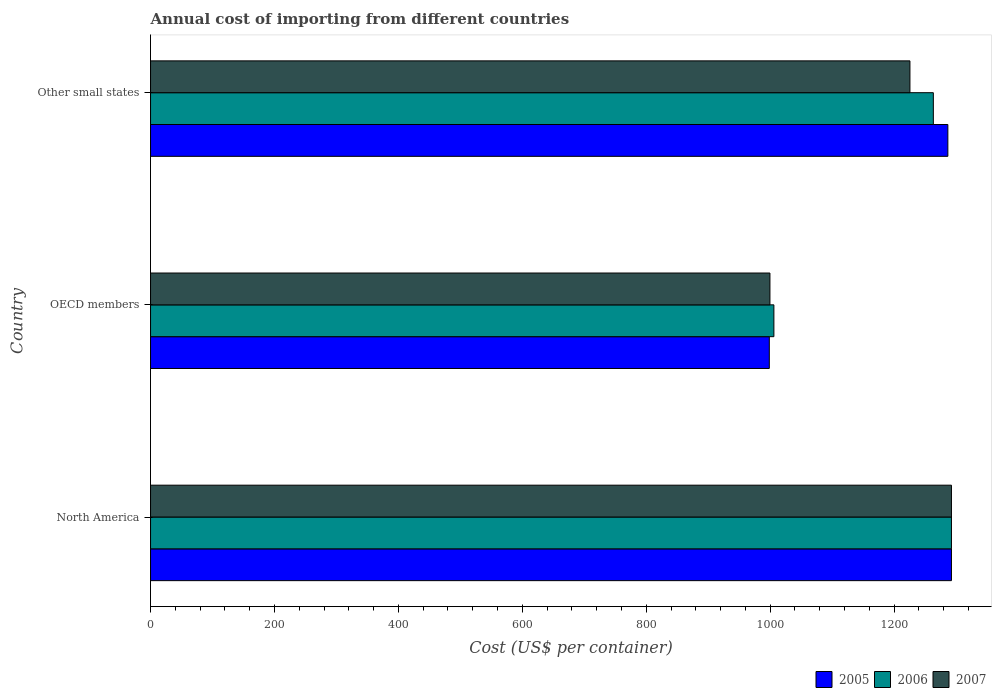How many different coloured bars are there?
Ensure brevity in your answer.  3. How many groups of bars are there?
Your answer should be compact. 3. Are the number of bars per tick equal to the number of legend labels?
Your response must be concise. Yes. Are the number of bars on each tick of the Y-axis equal?
Provide a short and direct response. Yes. How many bars are there on the 1st tick from the bottom?
Give a very brief answer. 3. What is the total annual cost of importing in 2005 in North America?
Your answer should be compact. 1292.5. Across all countries, what is the maximum total annual cost of importing in 2007?
Give a very brief answer. 1292.5. Across all countries, what is the minimum total annual cost of importing in 2007?
Provide a short and direct response. 999.59. In which country was the total annual cost of importing in 2006 maximum?
Offer a terse response. North America. In which country was the total annual cost of importing in 2005 minimum?
Give a very brief answer. OECD members. What is the total total annual cost of importing in 2006 in the graph?
Ensure brevity in your answer.  3561.75. What is the difference between the total annual cost of importing in 2006 in OECD members and that in Other small states?
Provide a succinct answer. -257.31. What is the difference between the total annual cost of importing in 2005 in North America and the total annual cost of importing in 2007 in OECD members?
Ensure brevity in your answer.  292.91. What is the average total annual cost of importing in 2007 per country?
Give a very brief answer. 1172.53. What is the difference between the total annual cost of importing in 2006 and total annual cost of importing in 2005 in OECD members?
Your answer should be compact. 7.39. What is the ratio of the total annual cost of importing in 2007 in North America to that in Other small states?
Provide a short and direct response. 1.05. What is the difference between the highest and the second highest total annual cost of importing in 2006?
Your answer should be compact. 29.22. What is the difference between the highest and the lowest total annual cost of importing in 2005?
Provide a succinct answer. 293.92. Is the sum of the total annual cost of importing in 2006 in OECD members and Other small states greater than the maximum total annual cost of importing in 2007 across all countries?
Keep it short and to the point. Yes. How many bars are there?
Your response must be concise. 9. How many countries are there in the graph?
Give a very brief answer. 3. What is the difference between two consecutive major ticks on the X-axis?
Offer a terse response. 200. Does the graph contain any zero values?
Ensure brevity in your answer.  No. How are the legend labels stacked?
Offer a very short reply. Horizontal. What is the title of the graph?
Provide a succinct answer. Annual cost of importing from different countries. Does "2012" appear as one of the legend labels in the graph?
Ensure brevity in your answer.  No. What is the label or title of the X-axis?
Offer a terse response. Cost (US$ per container). What is the label or title of the Y-axis?
Provide a short and direct response. Country. What is the Cost (US$ per container) of 2005 in North America?
Ensure brevity in your answer.  1292.5. What is the Cost (US$ per container) in 2006 in North America?
Provide a succinct answer. 1292.5. What is the Cost (US$ per container) of 2007 in North America?
Offer a terse response. 1292.5. What is the Cost (US$ per container) of 2005 in OECD members?
Keep it short and to the point. 998.58. What is the Cost (US$ per container) in 2006 in OECD members?
Offer a very short reply. 1005.97. What is the Cost (US$ per container) in 2007 in OECD members?
Offer a very short reply. 999.59. What is the Cost (US$ per container) in 2005 in Other small states?
Make the answer very short. 1286.71. What is the Cost (US$ per container) of 2006 in Other small states?
Your response must be concise. 1263.28. What is the Cost (US$ per container) of 2007 in Other small states?
Offer a terse response. 1225.5. Across all countries, what is the maximum Cost (US$ per container) of 2005?
Provide a short and direct response. 1292.5. Across all countries, what is the maximum Cost (US$ per container) in 2006?
Give a very brief answer. 1292.5. Across all countries, what is the maximum Cost (US$ per container) of 2007?
Your answer should be very brief. 1292.5. Across all countries, what is the minimum Cost (US$ per container) of 2005?
Ensure brevity in your answer.  998.58. Across all countries, what is the minimum Cost (US$ per container) of 2006?
Ensure brevity in your answer.  1005.97. Across all countries, what is the minimum Cost (US$ per container) in 2007?
Give a very brief answer. 999.59. What is the total Cost (US$ per container) of 2005 in the graph?
Offer a terse response. 3577.78. What is the total Cost (US$ per container) in 2006 in the graph?
Offer a terse response. 3561.75. What is the total Cost (US$ per container) of 2007 in the graph?
Your response must be concise. 3517.59. What is the difference between the Cost (US$ per container) in 2005 in North America and that in OECD members?
Keep it short and to the point. 293.92. What is the difference between the Cost (US$ per container) of 2006 in North America and that in OECD members?
Offer a very short reply. 286.53. What is the difference between the Cost (US$ per container) in 2007 in North America and that in OECD members?
Keep it short and to the point. 292.91. What is the difference between the Cost (US$ per container) of 2005 in North America and that in Other small states?
Provide a succinct answer. 5.79. What is the difference between the Cost (US$ per container) in 2006 in North America and that in Other small states?
Provide a succinct answer. 29.22. What is the difference between the Cost (US$ per container) of 2005 in OECD members and that in Other small states?
Your answer should be very brief. -288.13. What is the difference between the Cost (US$ per container) in 2006 in OECD members and that in Other small states?
Give a very brief answer. -257.31. What is the difference between the Cost (US$ per container) of 2007 in OECD members and that in Other small states?
Your response must be concise. -225.91. What is the difference between the Cost (US$ per container) of 2005 in North America and the Cost (US$ per container) of 2006 in OECD members?
Keep it short and to the point. 286.53. What is the difference between the Cost (US$ per container) in 2005 in North America and the Cost (US$ per container) in 2007 in OECD members?
Your answer should be very brief. 292.91. What is the difference between the Cost (US$ per container) in 2006 in North America and the Cost (US$ per container) in 2007 in OECD members?
Your answer should be compact. 292.91. What is the difference between the Cost (US$ per container) of 2005 in North America and the Cost (US$ per container) of 2006 in Other small states?
Your answer should be compact. 29.22. What is the difference between the Cost (US$ per container) in 2005 in OECD members and the Cost (US$ per container) in 2006 in Other small states?
Your answer should be compact. -264.7. What is the difference between the Cost (US$ per container) of 2005 in OECD members and the Cost (US$ per container) of 2007 in Other small states?
Your answer should be compact. -226.92. What is the difference between the Cost (US$ per container) of 2006 in OECD members and the Cost (US$ per container) of 2007 in Other small states?
Offer a very short reply. -219.53. What is the average Cost (US$ per container) of 2005 per country?
Keep it short and to the point. 1192.59. What is the average Cost (US$ per container) of 2006 per country?
Offer a very short reply. 1187.25. What is the average Cost (US$ per container) in 2007 per country?
Offer a terse response. 1172.53. What is the difference between the Cost (US$ per container) in 2005 and Cost (US$ per container) in 2007 in North America?
Offer a terse response. 0. What is the difference between the Cost (US$ per container) of 2006 and Cost (US$ per container) of 2007 in North America?
Provide a short and direct response. 0. What is the difference between the Cost (US$ per container) in 2005 and Cost (US$ per container) in 2006 in OECD members?
Your answer should be very brief. -7.39. What is the difference between the Cost (US$ per container) of 2005 and Cost (US$ per container) of 2007 in OECD members?
Give a very brief answer. -1.01. What is the difference between the Cost (US$ per container) of 2006 and Cost (US$ per container) of 2007 in OECD members?
Provide a succinct answer. 6.38. What is the difference between the Cost (US$ per container) in 2005 and Cost (US$ per container) in 2006 in Other small states?
Your answer should be compact. 23.43. What is the difference between the Cost (US$ per container) of 2005 and Cost (US$ per container) of 2007 in Other small states?
Provide a short and direct response. 61.21. What is the difference between the Cost (US$ per container) in 2006 and Cost (US$ per container) in 2007 in Other small states?
Offer a terse response. 37.78. What is the ratio of the Cost (US$ per container) of 2005 in North America to that in OECD members?
Ensure brevity in your answer.  1.29. What is the ratio of the Cost (US$ per container) in 2006 in North America to that in OECD members?
Provide a short and direct response. 1.28. What is the ratio of the Cost (US$ per container) in 2007 in North America to that in OECD members?
Your answer should be compact. 1.29. What is the ratio of the Cost (US$ per container) in 2005 in North America to that in Other small states?
Your answer should be compact. 1. What is the ratio of the Cost (US$ per container) of 2006 in North America to that in Other small states?
Provide a short and direct response. 1.02. What is the ratio of the Cost (US$ per container) of 2007 in North America to that in Other small states?
Your answer should be compact. 1.05. What is the ratio of the Cost (US$ per container) in 2005 in OECD members to that in Other small states?
Keep it short and to the point. 0.78. What is the ratio of the Cost (US$ per container) in 2006 in OECD members to that in Other small states?
Keep it short and to the point. 0.8. What is the ratio of the Cost (US$ per container) in 2007 in OECD members to that in Other small states?
Offer a terse response. 0.82. What is the difference between the highest and the second highest Cost (US$ per container) in 2005?
Your response must be concise. 5.79. What is the difference between the highest and the second highest Cost (US$ per container) in 2006?
Give a very brief answer. 29.22. What is the difference between the highest and the lowest Cost (US$ per container) of 2005?
Make the answer very short. 293.92. What is the difference between the highest and the lowest Cost (US$ per container) of 2006?
Your response must be concise. 286.53. What is the difference between the highest and the lowest Cost (US$ per container) of 2007?
Keep it short and to the point. 292.91. 